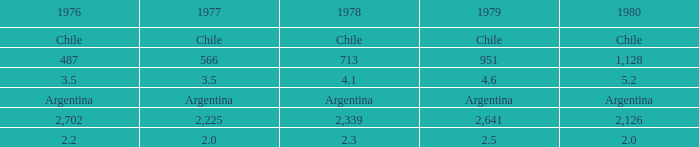If 1977 is equivalent to 3.5, what would be the value of 1976? 3.5. 